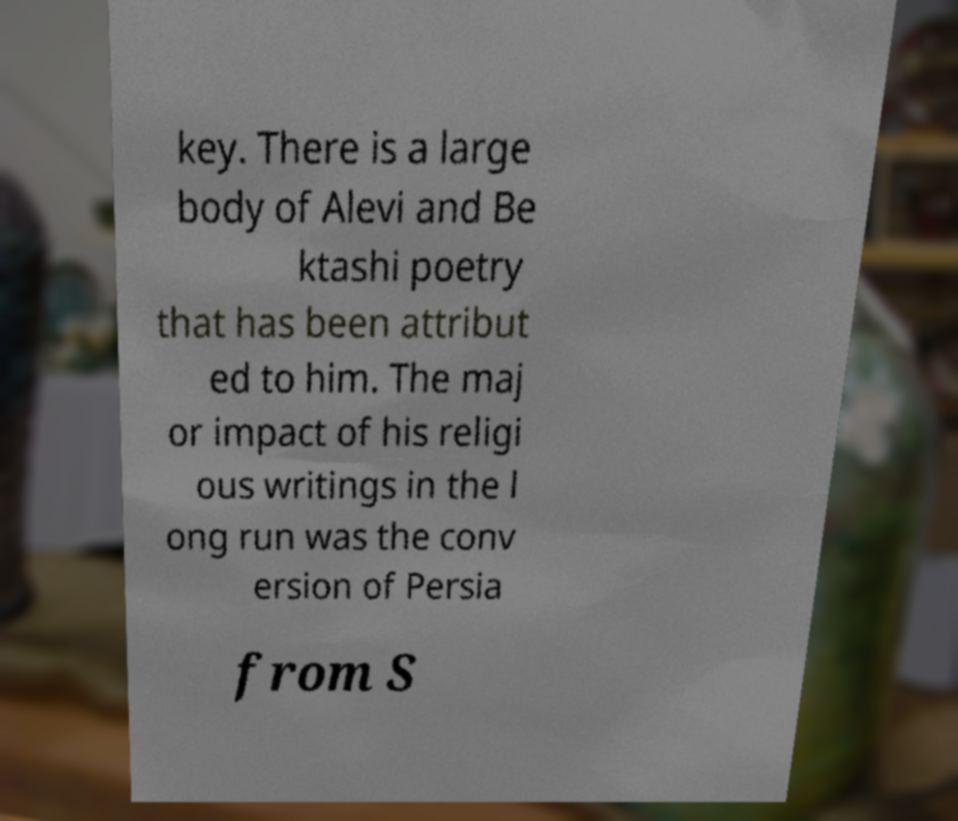Can you accurately transcribe the text from the provided image for me? key. There is a large body of Alevi and Be ktashi poetry that has been attribut ed to him. The maj or impact of his religi ous writings in the l ong run was the conv ersion of Persia from S 